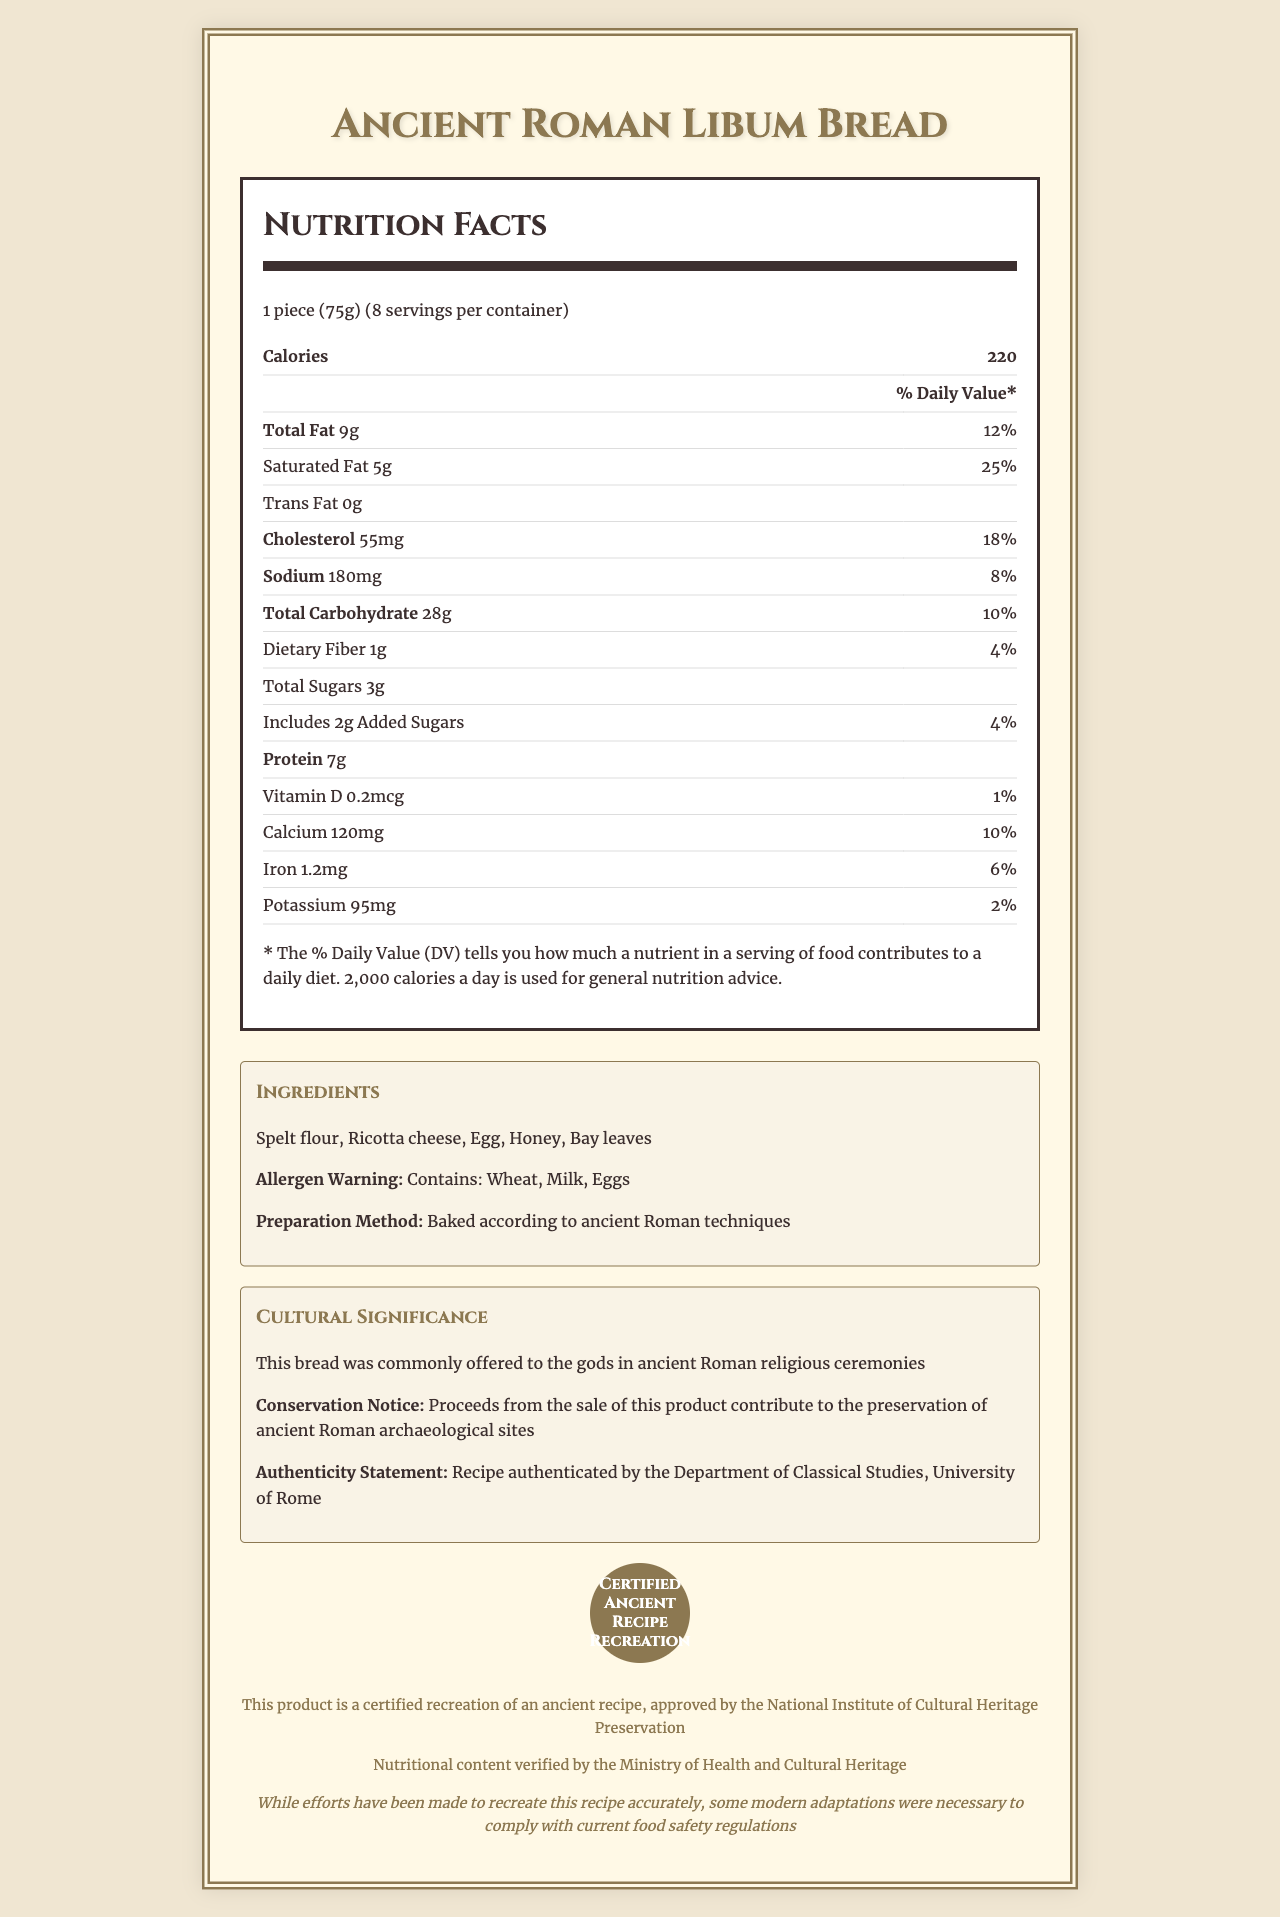Who is the product name of the item? The product name is stated at the beginning of the document.
Answer: Ancient Roman Libum Bread What is the serving size of the Ancient Roman Libum Bread? The serving size is listed below the Nutrition Facts label.
Answer: 1 piece (75g) How many servings are there per container? The servings per container are specified next to the serving size.
Answer: 8 How many calories are in one serving? The number of calories per serving is listed at the top of the Nutrition Facts label under the bold heading 'Calories'.
Answer: 220 What percentage of the daily value is the total fat? The daily value percentage for total fat is listed next to the total fat amount in the Nutrition Facts label.
Answer: 12% Which ingredient is not mentioned in the list? A. Spelt flour B. Ricotta cheese C. Almond flour D. Honey Almond flour is not listed in the ingredients; Spelt flour, Ricotta cheese, and Honey are listed.
Answer: C. Almond flour What type of fat is absent in the product? A. Saturated Fat B. Trans Fat C. Cholesterol D. Total Fat The document lists "Trans Fat 0g," indicating that Trans Fat is absent.
Answer: B. Trans Fat Is the product gluten-free? The allergen warning specifies that the product contains wheat.
Answer: No Does the product include any initiative for cultural heritage preservation? The product states that proceeds contribute to preserving ancient Roman archaeological sites.
Answer: Yes Summarize the main idea of the document. The document includes a nutrition facts label, ingredients, allergen information, cultural significance, and various disclaimers and certifications, emphasizing the authenticity and cultural contributions of the product.
Answer: The Ancient Roman Libum Bread is a modern recreation of a historical recipe, providing both nutritional information and cultural significance. It is a certified and authentic recipe, contributing to cultural heritage preservation. What is the protein content per serving? The protein content is listed in the Nutrition Facts label as 7g per serving.
Answer: 7g How much cholesterol does one serving contain? The amount of cholesterol per serving is specified in the Nutrition Facts label.
Answer: 55mg What is the daily value percentage of calcium? The daily value percentage for calcium is listed next to the amount in the Nutrition Facts label.
Answer: 10% How many total sugars are there in one serving? The amount of total sugars is provided in the Nutrition Facts label.
Answer: 3g What is the method of preparation for the bread? The method of preparation is provided in the ingredients section.
Answer: Baked according to ancient Roman techniques Who has authenticated the recipe for this product? The authenticity statement mentions that the recipe is authenticated by the Department of Classical Studies, University of Rome.
Answer: Department of Classical Studies, University of Rome How much funding from each sale helps protect archaeological sites? The document states that proceeds contribute to preservation, but it does not specify the exact amount allocated per sale.
Answer: Cannot be determined 